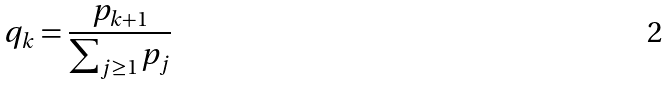<formula> <loc_0><loc_0><loc_500><loc_500>q _ { k } = \frac { p _ { k + 1 } } { \sum _ { j \geq 1 } p _ { j } }</formula> 